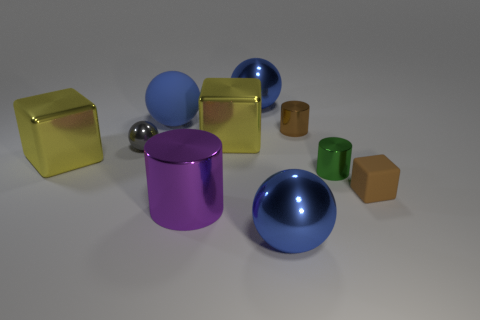Does the brown metal thing have the same size as the purple object?
Offer a terse response. No. There is a large object that is in front of the big blue matte sphere and behind the small ball; what shape is it?
Make the answer very short. Cube. How many brown things are the same material as the brown cylinder?
Your answer should be very brief. 0. How many tiny brown objects are in front of the tiny brown metal object that is behind the purple shiny object?
Make the answer very short. 1. There is a big blue metal thing left of the large blue shiny object in front of the tiny brown object that is on the left side of the brown rubber object; what is its shape?
Keep it short and to the point. Sphere. The shiny object that is the same color as the matte cube is what size?
Provide a short and direct response. Small. What number of things are either large blue matte balls or tiny green metallic cylinders?
Keep it short and to the point. 2. There is a shiny sphere that is the same size as the brown matte cube; what is its color?
Ensure brevity in your answer.  Gray. Is the shape of the big purple thing the same as the small shiny object that is on the right side of the brown metal object?
Offer a very short reply. Yes. How many things are big shiny objects in front of the tiny brown block or big blue metal objects that are in front of the big rubber thing?
Offer a very short reply. 2. 